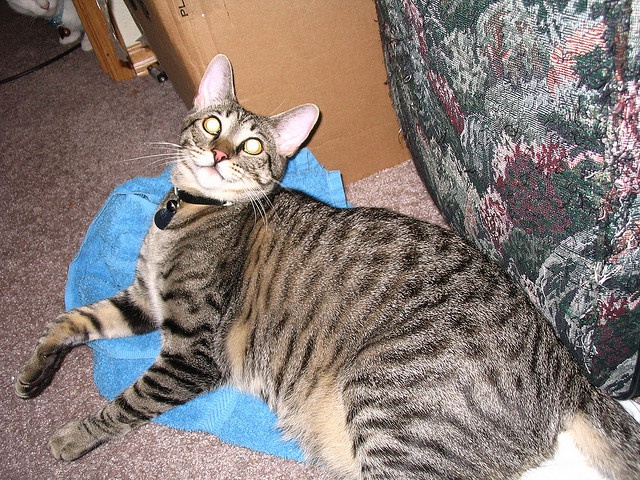Describe the objects in this image and their specific colors. I can see a cat in black, gray, darkgray, and lightgray tones in this image. 